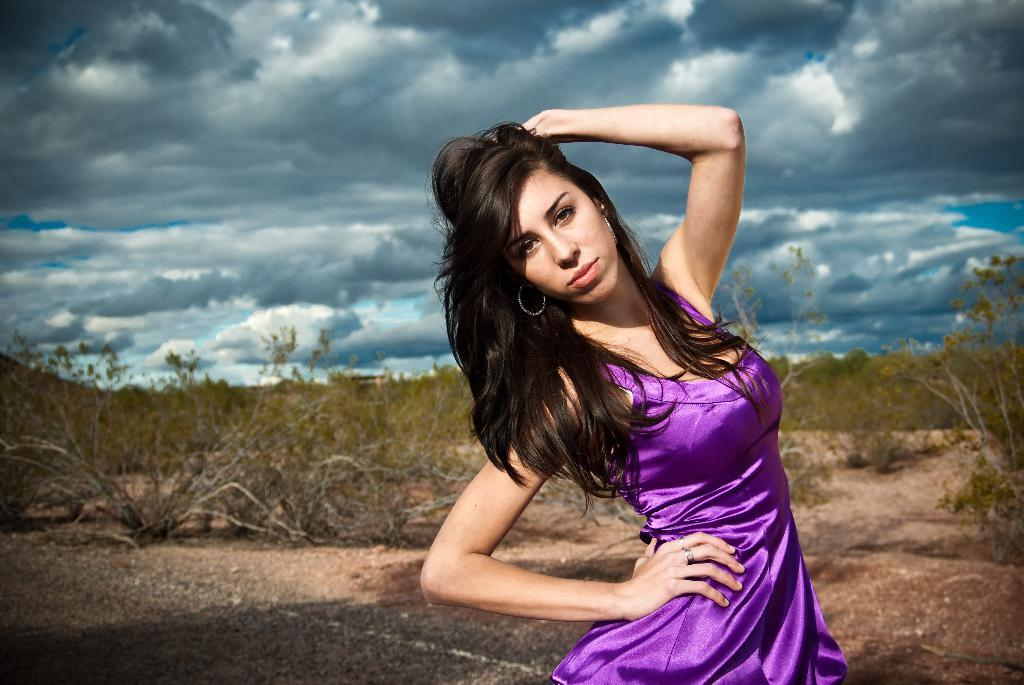Who is present in the image? There is a woman in the image. What is the woman wearing? The woman is wearing a purple dress. What type of natural environment can be seen in the image? There are trees in the image. What is visible in the background of the image? The sky is visible in the image. What substance is the woman using to lift the trees in the image? There is no substance or lifting action involving the woman and the trees in the image. 